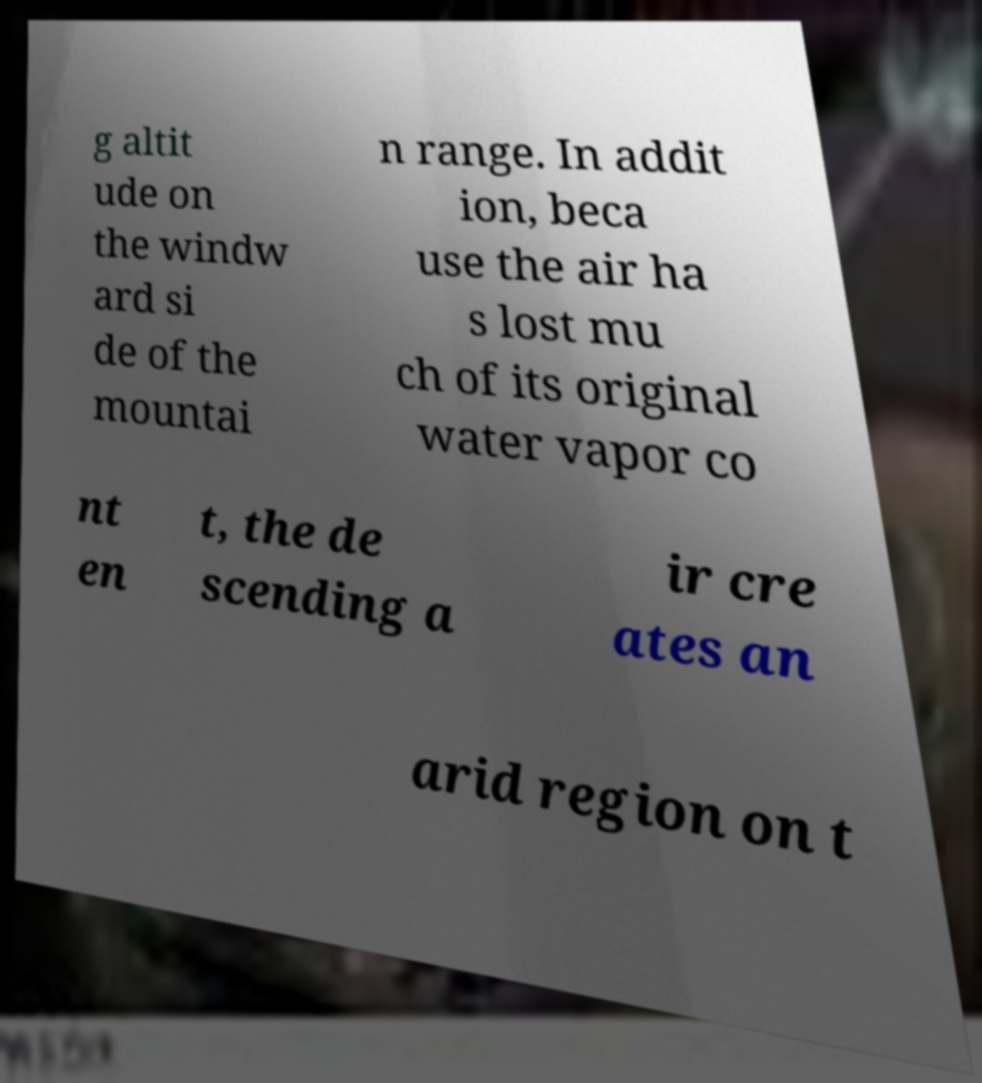Please identify and transcribe the text found in this image. g altit ude on the windw ard si de of the mountai n range. In addit ion, beca use the air ha s lost mu ch of its original water vapor co nt en t, the de scending a ir cre ates an arid region on t 